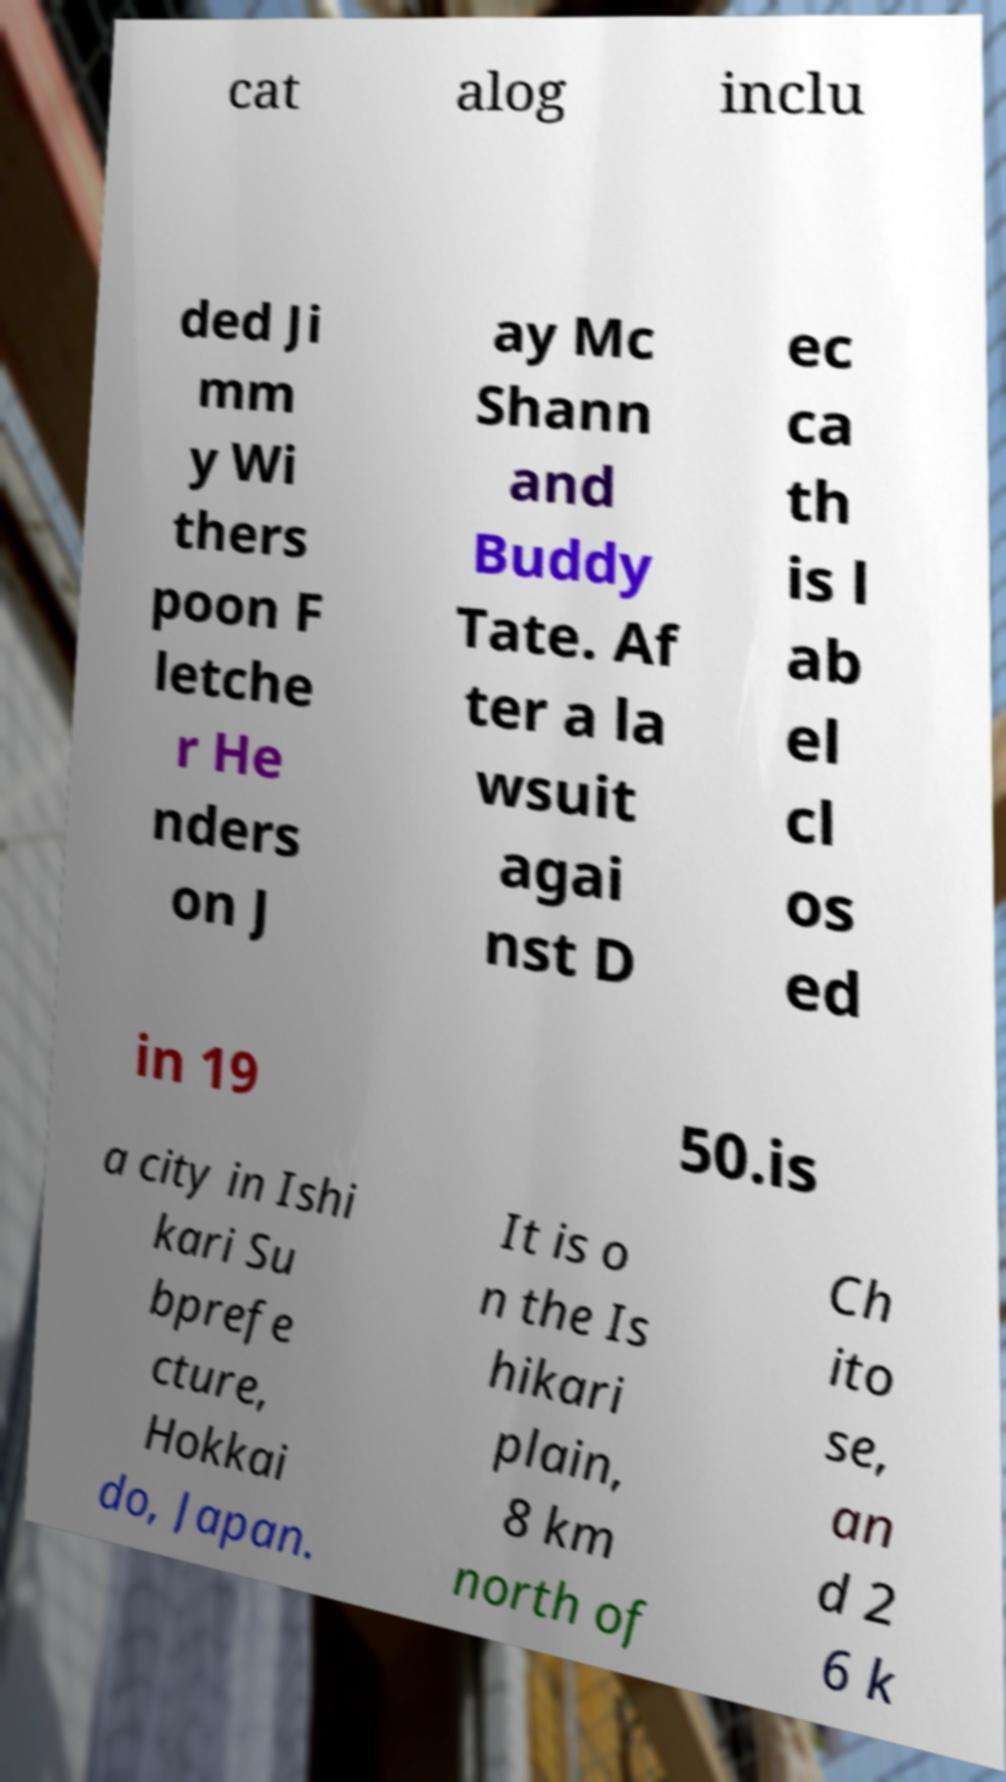Please identify and transcribe the text found in this image. cat alog inclu ded Ji mm y Wi thers poon F letche r He nders on J ay Mc Shann and Buddy Tate. Af ter a la wsuit agai nst D ec ca th is l ab el cl os ed in 19 50.is a city in Ishi kari Su bprefe cture, Hokkai do, Japan. It is o n the Is hikari plain, 8 km north of Ch ito se, an d 2 6 k 